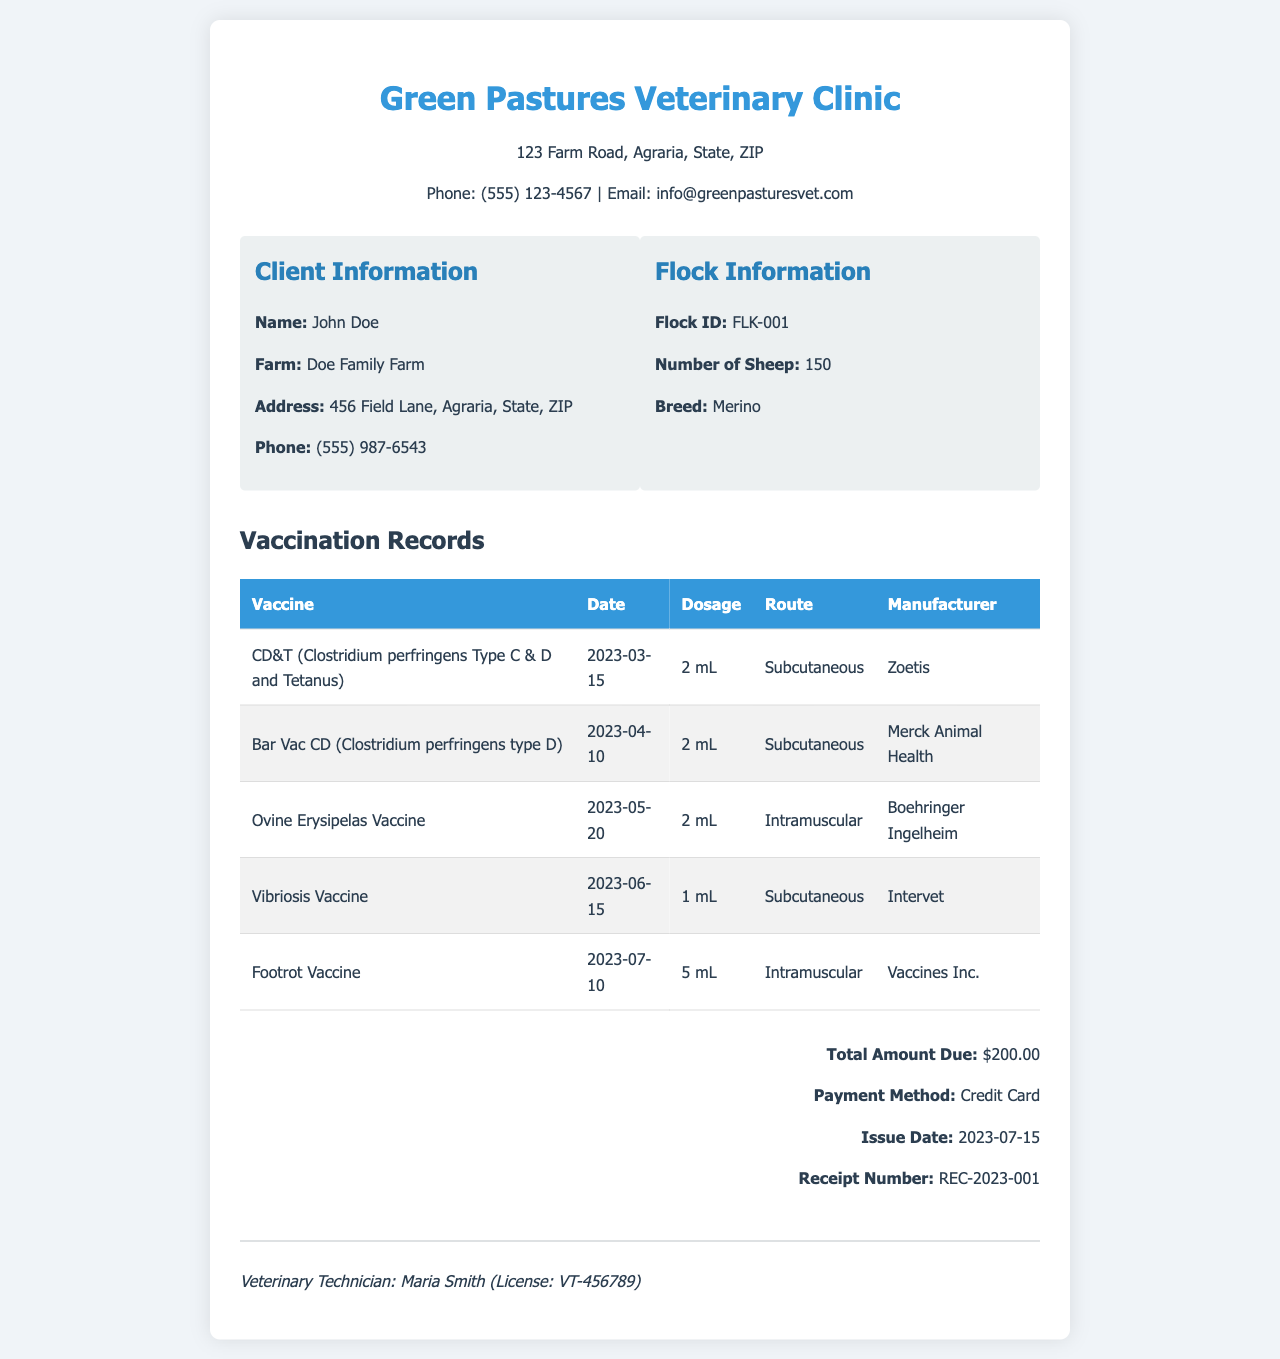What is the name of the veterinary clinic? The name of the veterinary clinic is provided in the header of the document.
Answer: Green Pastures Veterinary Clinic Who is the client? The client information is located in the client information section of the document.
Answer: John Doe How many sheep are in the flock? The number of sheep is mentioned in the flock information section.
Answer: 150 What vaccination was administered on April 10, 2023? The vaccination records table lists the vaccines along with their dates of administration.
Answer: Bar Vac CD (Clostridium perfringens type D) What is the total amount due? The total amount due is specified in the footer of the document.
Answer: $200.00 What route was used for the Vibriosis Vaccine? The vaccination records table includes the administration route for each vaccine.
Answer: Subcutaneous When was the Footrot Vaccine administered? The date for the Footrot Vaccine is found in the vaccination records section of the document.
Answer: 2023-07-10 Who is the veterinary technician? The signature section of the document provides the name of the veterinary technician.
Answer: Maria Smith What is the receipt number? The receipt number is included in the footer of the document.
Answer: REC-2023-001 